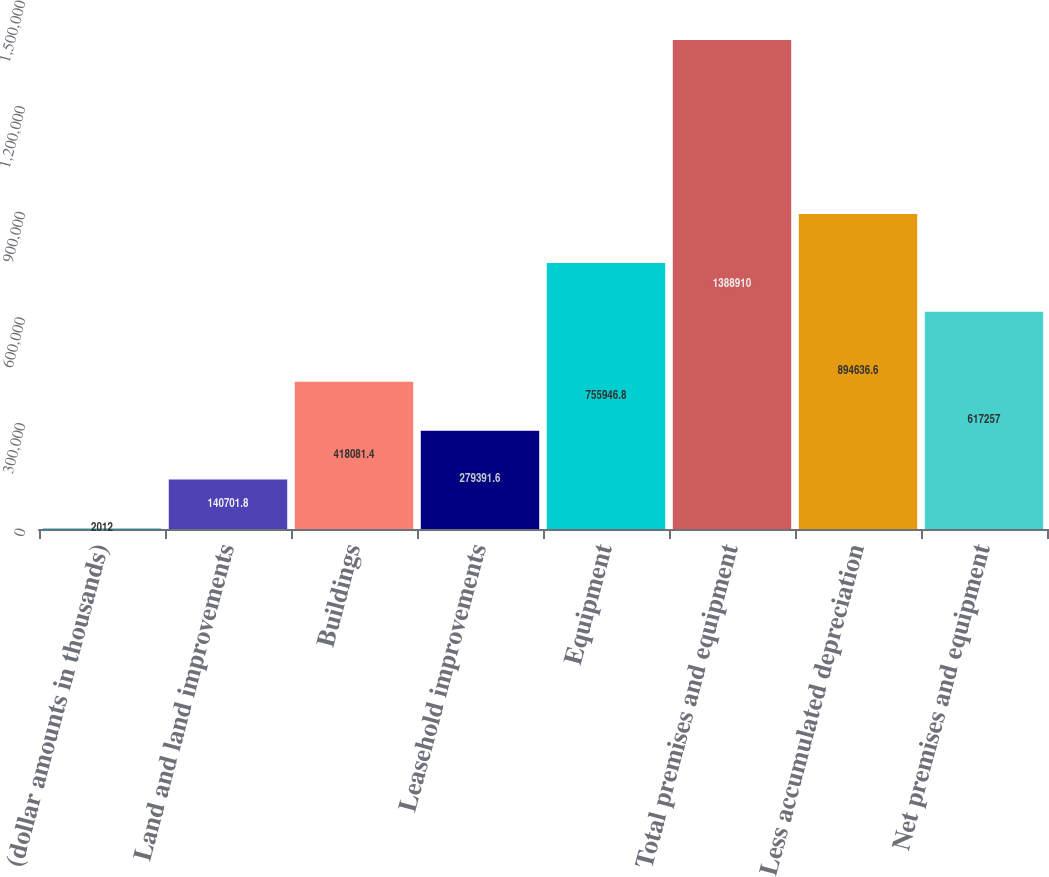Convert chart. <chart><loc_0><loc_0><loc_500><loc_500><bar_chart><fcel>(dollar amounts in thousands)<fcel>Land and land improvements<fcel>Buildings<fcel>Leasehold improvements<fcel>Equipment<fcel>Total premises and equipment<fcel>Less accumulated depreciation<fcel>Net premises and equipment<nl><fcel>2012<fcel>140702<fcel>418081<fcel>279392<fcel>755947<fcel>1.38891e+06<fcel>894637<fcel>617257<nl></chart> 